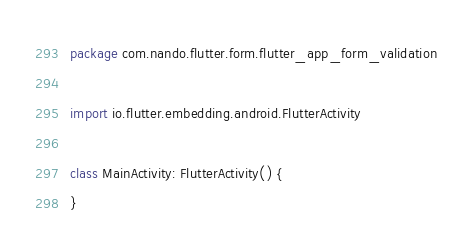<code> <loc_0><loc_0><loc_500><loc_500><_Kotlin_>package com.nando.flutter.form.flutter_app_form_validation

import io.flutter.embedding.android.FlutterActivity

class MainActivity: FlutterActivity() {
}
</code> 